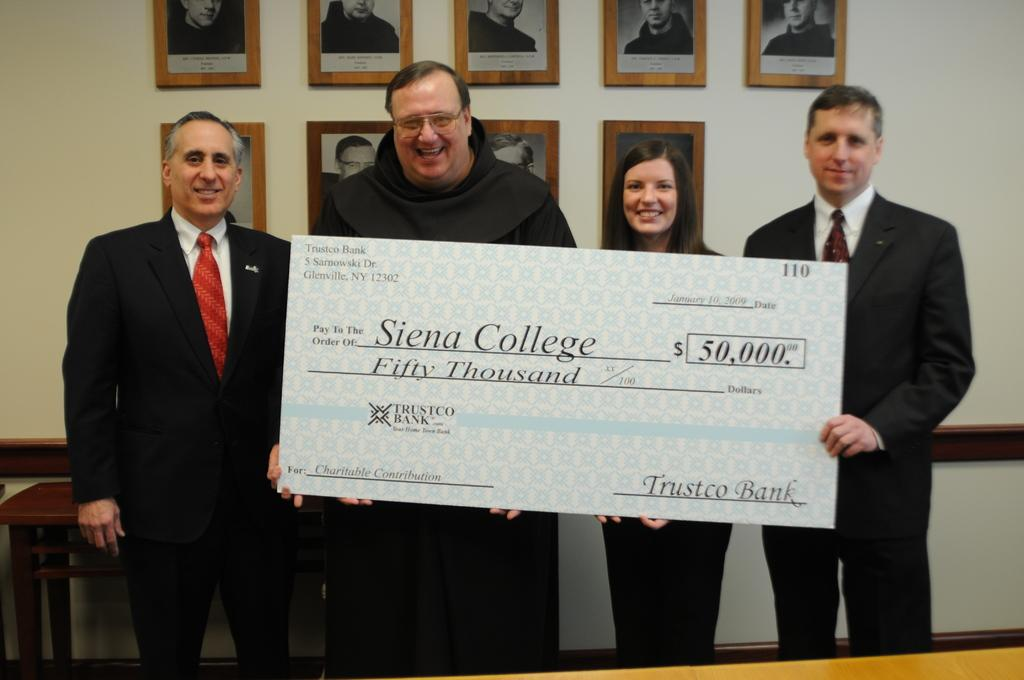How many people are in the image? There are persons in the image, but the exact number is not specified. What are some of the persons holding in the image? Some persons are holding a big cheque in the image. What can be seen in the background of the image? There is a table and frames on the wall in the background of the image. What type of silk is draped over the bucket in the image? There is no bucket or silk present in the image. Who is the representative of the group in the image? The facts do not mention any group or representative, so it cannot be determined from the image. 